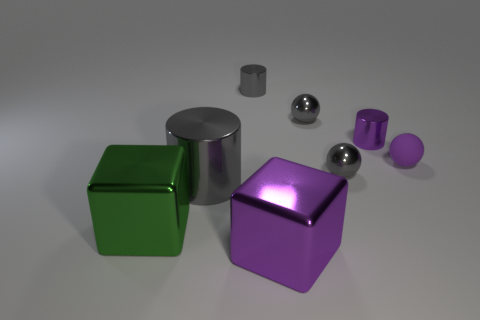There is a small purple matte thing; what number of green metallic blocks are right of it?
Your answer should be very brief. 0. Are there any yellow matte spheres that have the same size as the purple cube?
Keep it short and to the point. No. Is the big metallic cylinder the same color as the tiny matte sphere?
Provide a succinct answer. No. What color is the large metallic cube that is on the left side of the large object behind the green thing?
Provide a succinct answer. Green. What number of things are on the left side of the big purple cube and behind the big cylinder?
Ensure brevity in your answer.  1. How many gray things have the same shape as the big purple thing?
Your answer should be very brief. 0. Is the material of the small purple sphere the same as the tiny gray cylinder?
Your answer should be compact. No. What shape is the large purple thing on the left side of the purple thing that is behind the tiny rubber object?
Offer a terse response. Cube. How many large purple shiny cubes are behind the tiny shiny object in front of the tiny matte object?
Keep it short and to the point. 0. The cylinder that is both to the left of the purple metal cylinder and behind the purple ball is made of what material?
Give a very brief answer. Metal. 